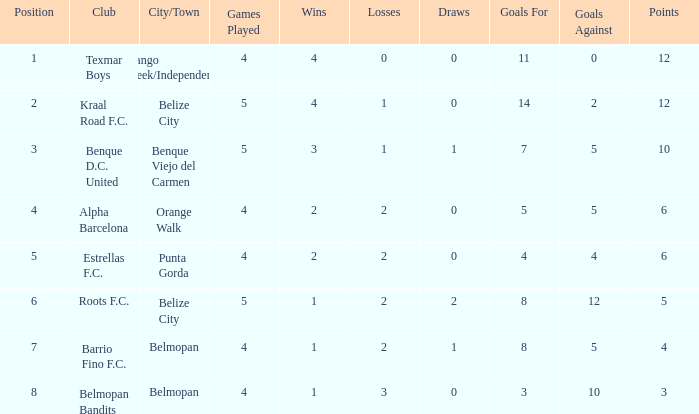What is the minimum points with goals for/against being 8-5 4.0. 